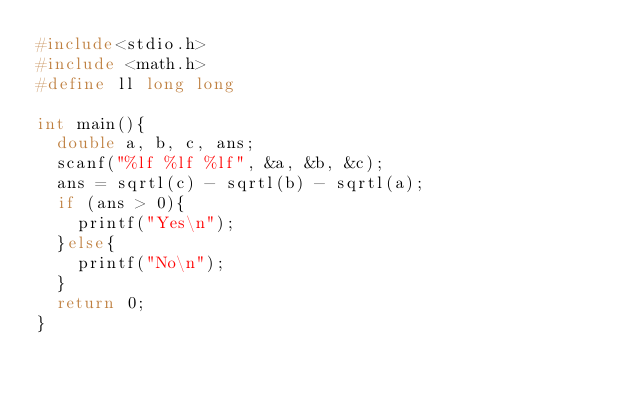Convert code to text. <code><loc_0><loc_0><loc_500><loc_500><_C_>#include<stdio.h>
#include <math.h>
#define ll long long

int main(){
  double a, b, c, ans;
  scanf("%lf %lf %lf", &a, &b, &c);
  ans = sqrtl(c) - sqrtl(b) - sqrtl(a);
  if (ans > 0){
    printf("Yes\n");
  }else{
    printf("No\n");
  }
  return 0;
}</code> 